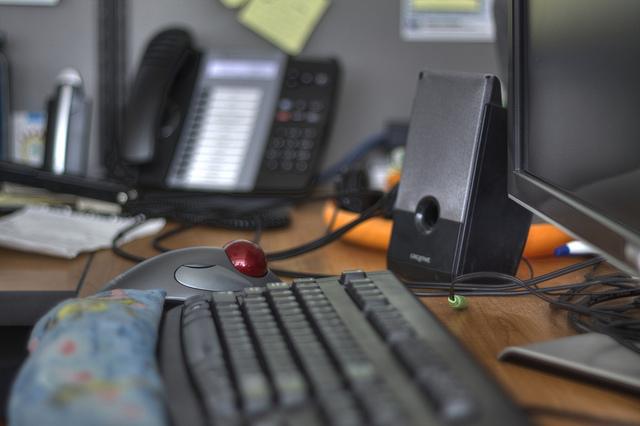What color ball is in the mouse?
Concise answer only. Red. Can I make a telephone call while sitting at this desk?
Write a very short answer. Yes. Is the monitor turned on?
Quick response, please. No. 